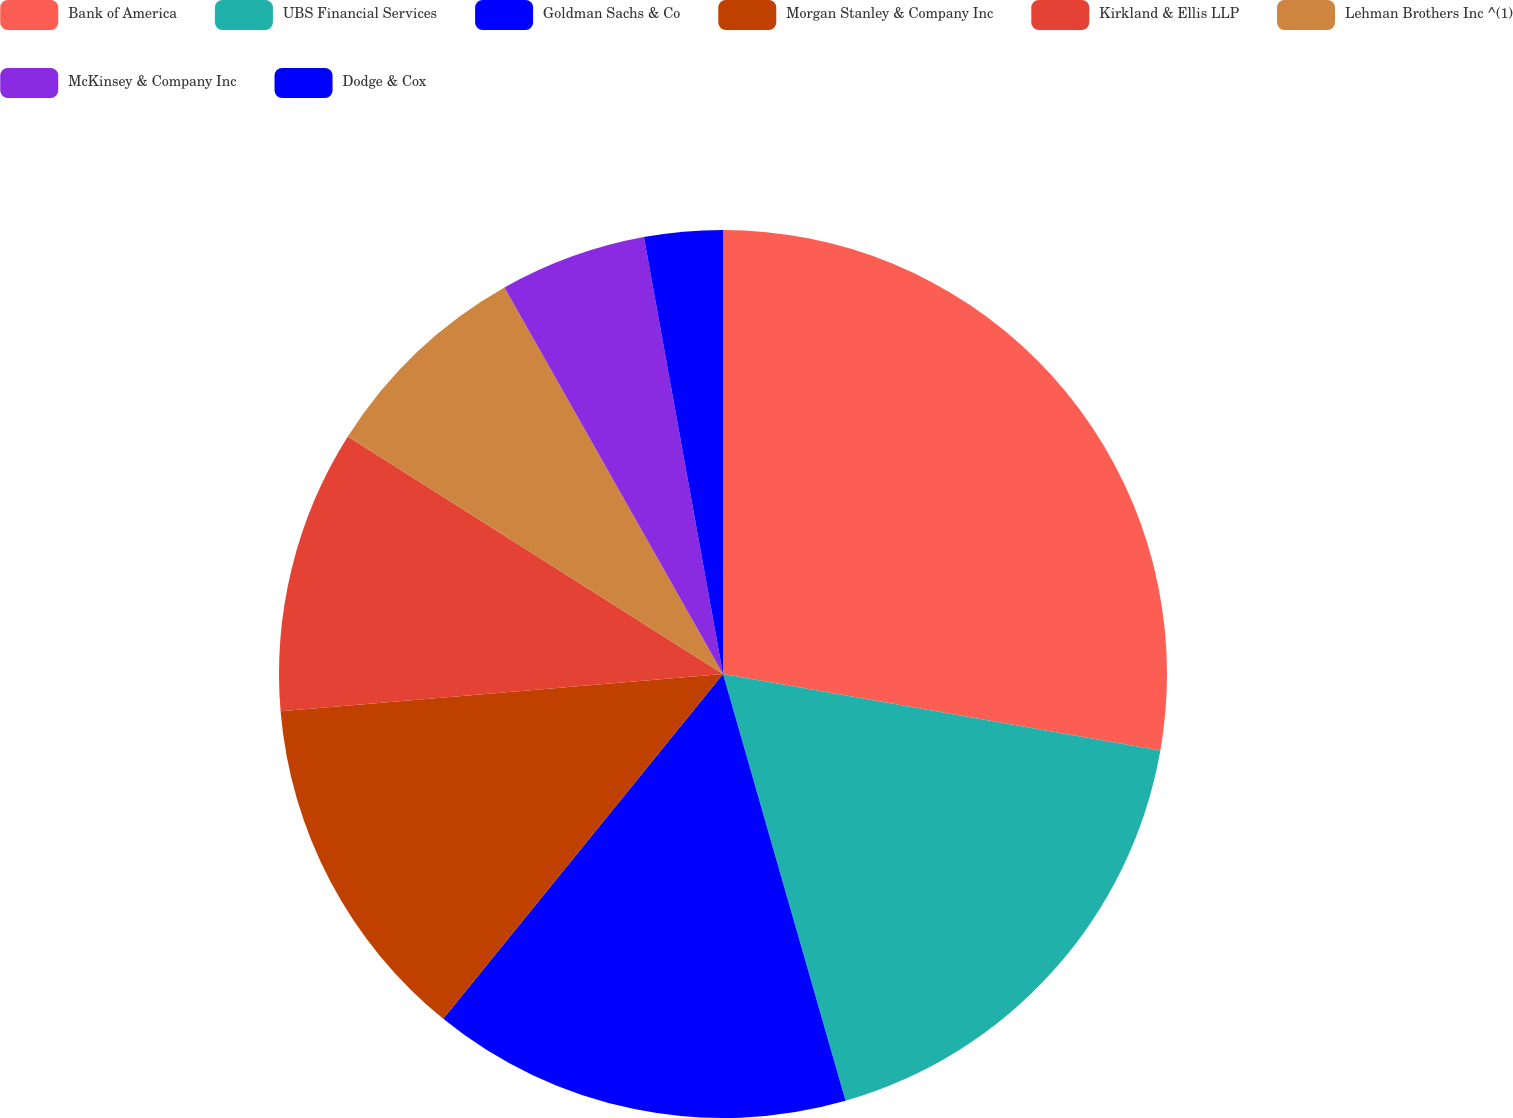<chart> <loc_0><loc_0><loc_500><loc_500><pie_chart><fcel>Bank of America<fcel>UBS Financial Services<fcel>Goldman Sachs & Co<fcel>Morgan Stanley & Company Inc<fcel>Kirkland & Ellis LLP<fcel>Lehman Brothers Inc ^(1)<fcel>McKinsey & Company Inc<fcel>Dodge & Cox<nl><fcel>27.76%<fcel>17.79%<fcel>15.3%<fcel>12.81%<fcel>10.32%<fcel>7.83%<fcel>5.34%<fcel>2.85%<nl></chart> 